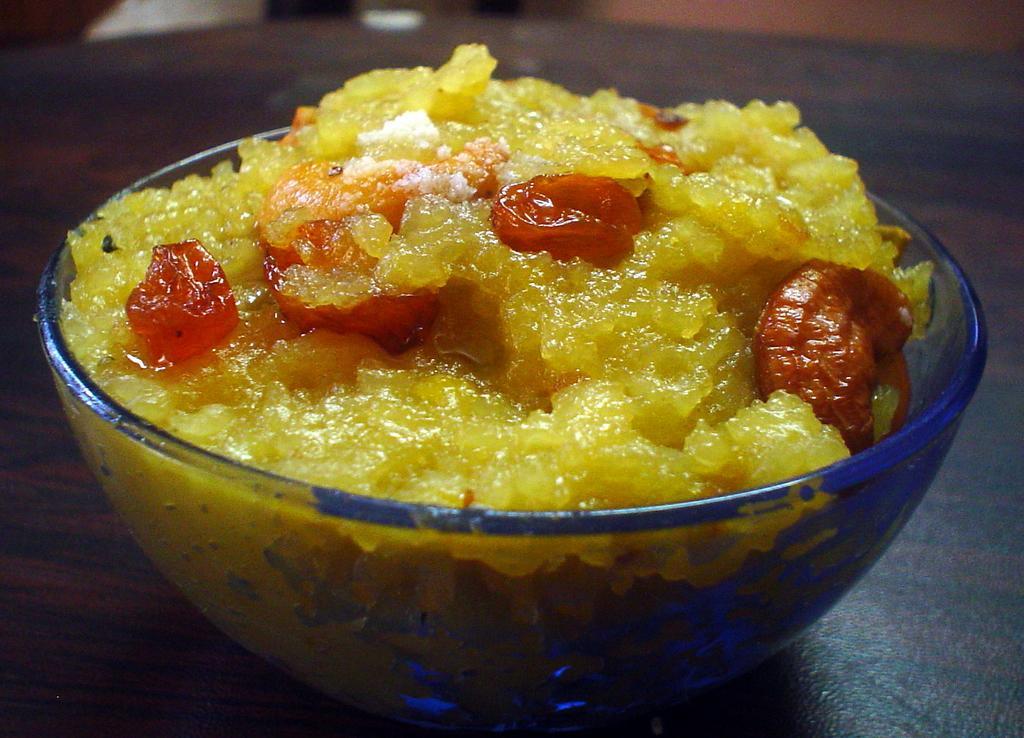Can you describe this image briefly? On the table we can see glass bowl. In the glass bowl we can see yellow color sweet and red color jerry. On the top right there is a wall. 